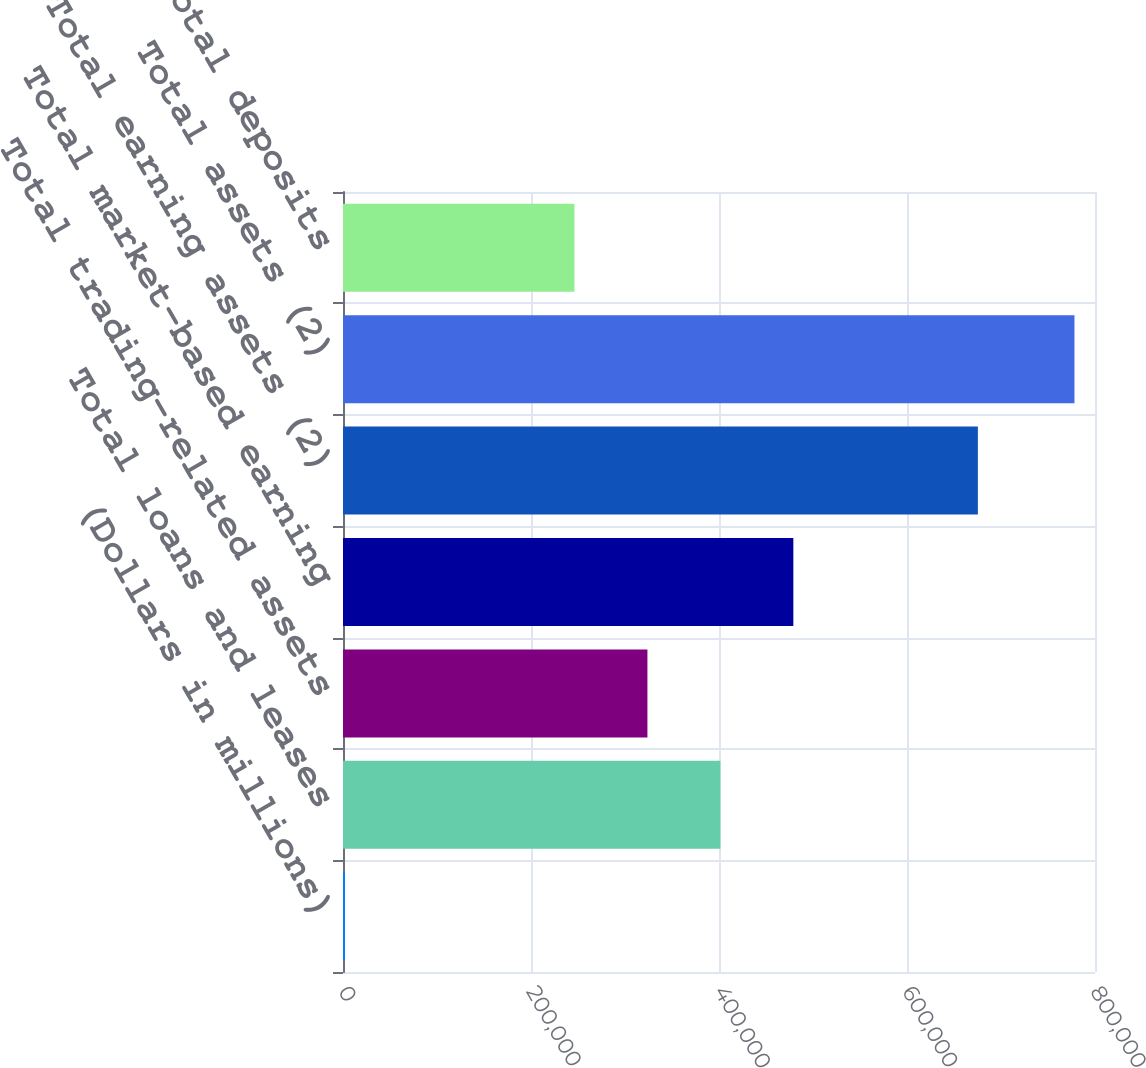<chart> <loc_0><loc_0><loc_500><loc_500><bar_chart><fcel>(Dollars in millions)<fcel>Total loans and leases<fcel>Total trading-related assets<fcel>Total market-based earning<fcel>Total earning assets (2)<fcel>Total assets (2)<fcel>Total deposits<nl><fcel>2007<fcel>401472<fcel>323857<fcel>479087<fcel>675407<fcel>778158<fcel>246242<nl></chart> 